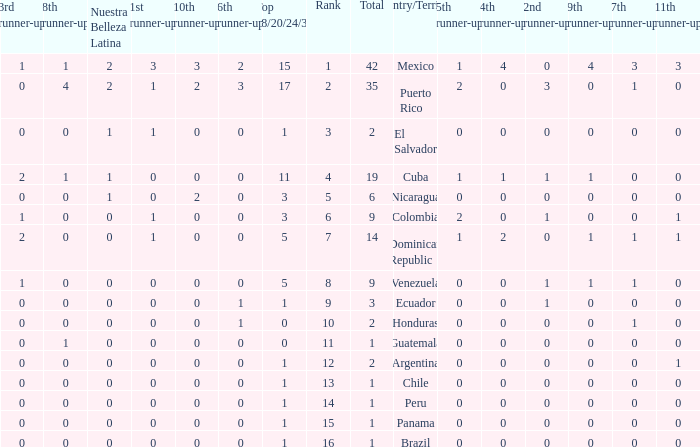What is the lowest 7th runner-up of the country with a top 18/20/24/30 greater than 5, a 1st runner-up greater than 0, and an 11th runner-up less than 0? None. 